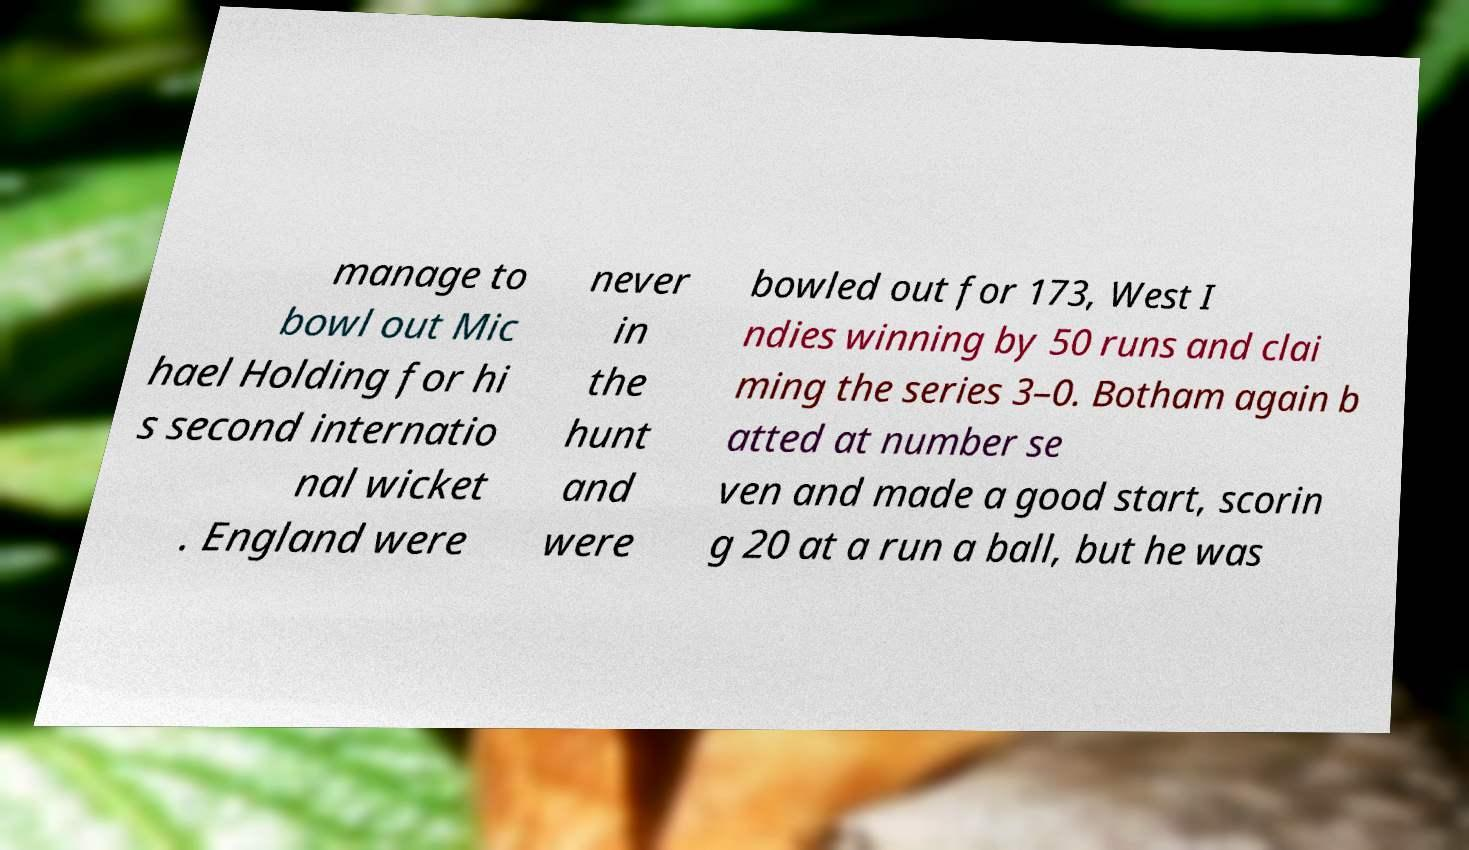I need the written content from this picture converted into text. Can you do that? manage to bowl out Mic hael Holding for hi s second internatio nal wicket . England were never in the hunt and were bowled out for 173, West I ndies winning by 50 runs and clai ming the series 3–0. Botham again b atted at number se ven and made a good start, scorin g 20 at a run a ball, but he was 